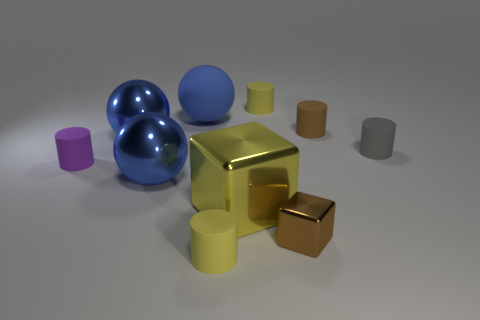How many yellow cylinders must be subtracted to get 1 yellow cylinders? 1 Subtract all large metal spheres. How many spheres are left? 1 Subtract all red balls. How many yellow cylinders are left? 2 Subtract 3 cylinders. How many cylinders are left? 2 Subtract all gray cylinders. How many cylinders are left? 4 Subtract all spheres. How many objects are left? 7 Subtract all green cylinders. Subtract all blue balls. How many cylinders are left? 5 Add 4 big rubber balls. How many big rubber balls are left? 5 Add 4 metallic objects. How many metallic objects exist? 8 Subtract 1 purple cylinders. How many objects are left? 9 